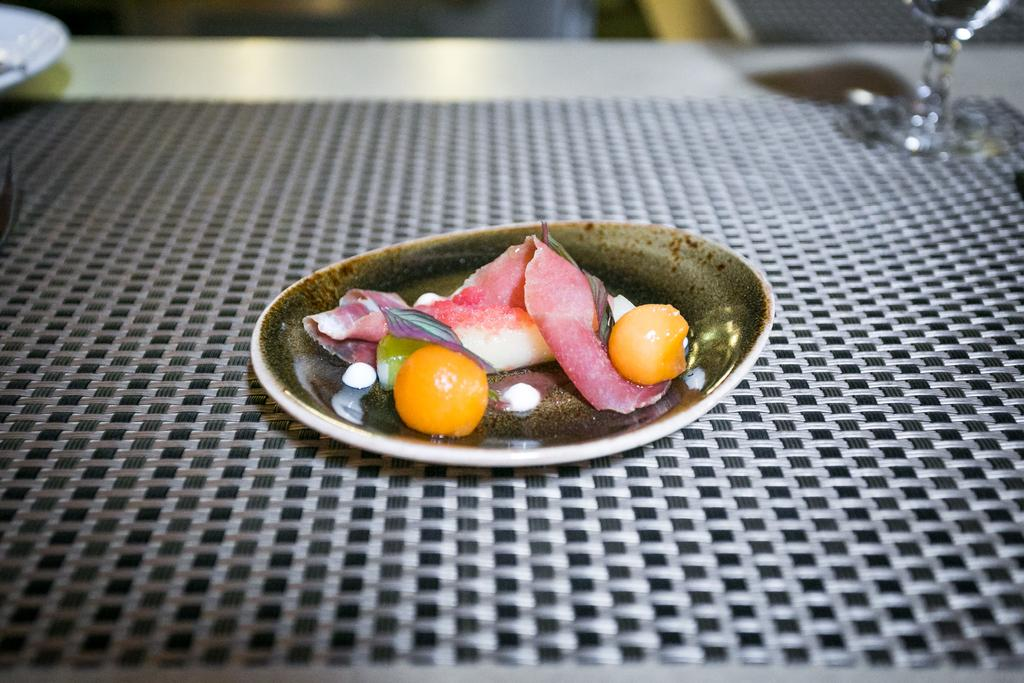What is on the plate that is visible in the image? There is food in a plate in the image. Where is the plate with food located? The plate with food is placed on a table. What else can be seen on the table in the image? There is a plate beside the food plate and a glass beside the plates in the image. How much does the woman weigh in the image? There is no woman present in the image, so her weight cannot be determined. 